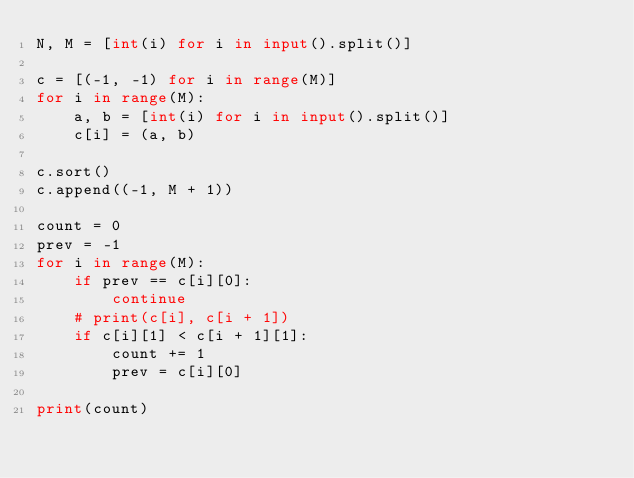<code> <loc_0><loc_0><loc_500><loc_500><_Python_>N, M = [int(i) for i in input().split()]

c = [(-1, -1) for i in range(M)]
for i in range(M):
    a, b = [int(i) for i in input().split()]
    c[i] = (a, b)

c.sort()
c.append((-1, M + 1))

count = 0
prev = -1
for i in range(M):
    if prev == c[i][0]:
        continue
    # print(c[i], c[i + 1])
    if c[i][1] < c[i + 1][1]:
        count += 1
        prev = c[i][0]

print(count)
</code> 